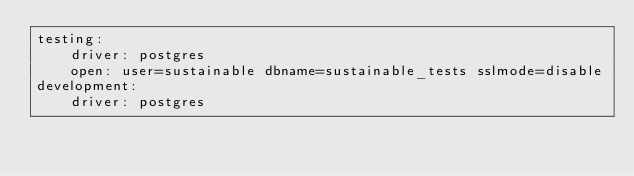<code> <loc_0><loc_0><loc_500><loc_500><_YAML_>testing:
    driver: postgres
    open: user=sustainable dbname=sustainable_tests sslmode=disable
development:
    driver: postgres</code> 